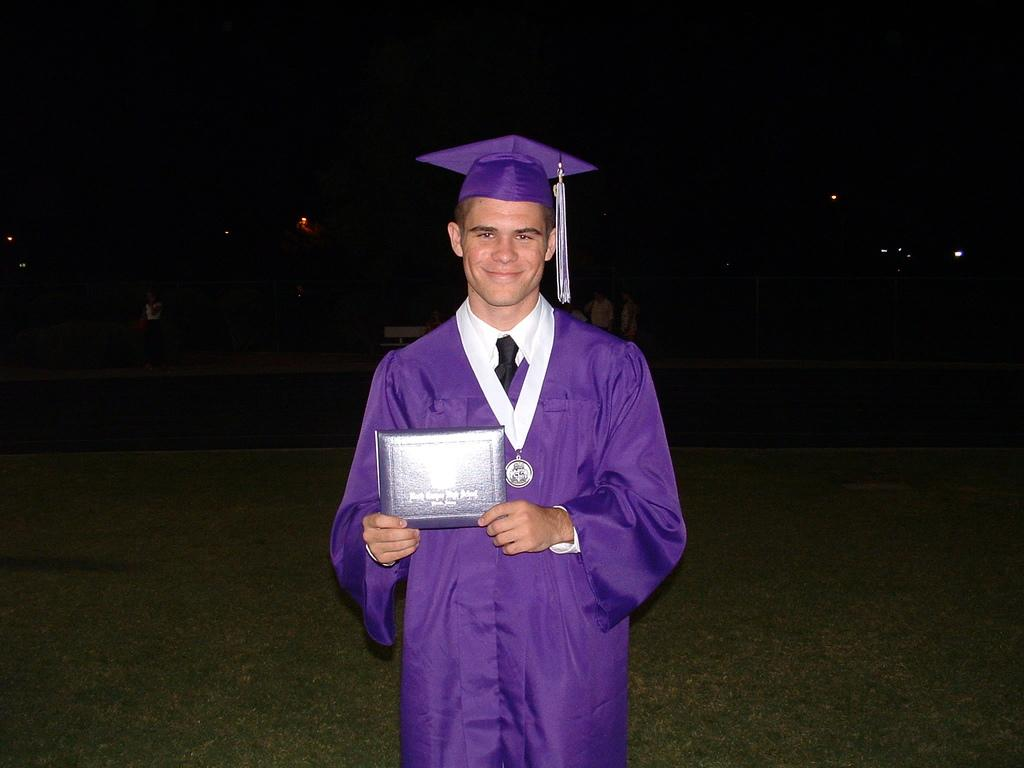Who is the main subject in the image? There is a boy in the image. What is the boy wearing? The boy is wearing a purple convocation dress and a cap on his head. What is the boy holding in his hand? The boy is holding a degree in his hand. Where is the boy standing? The boy is standing on a grass lawn. What type of powder is visible on the roof in the image? There is no roof or powder present in the image. 